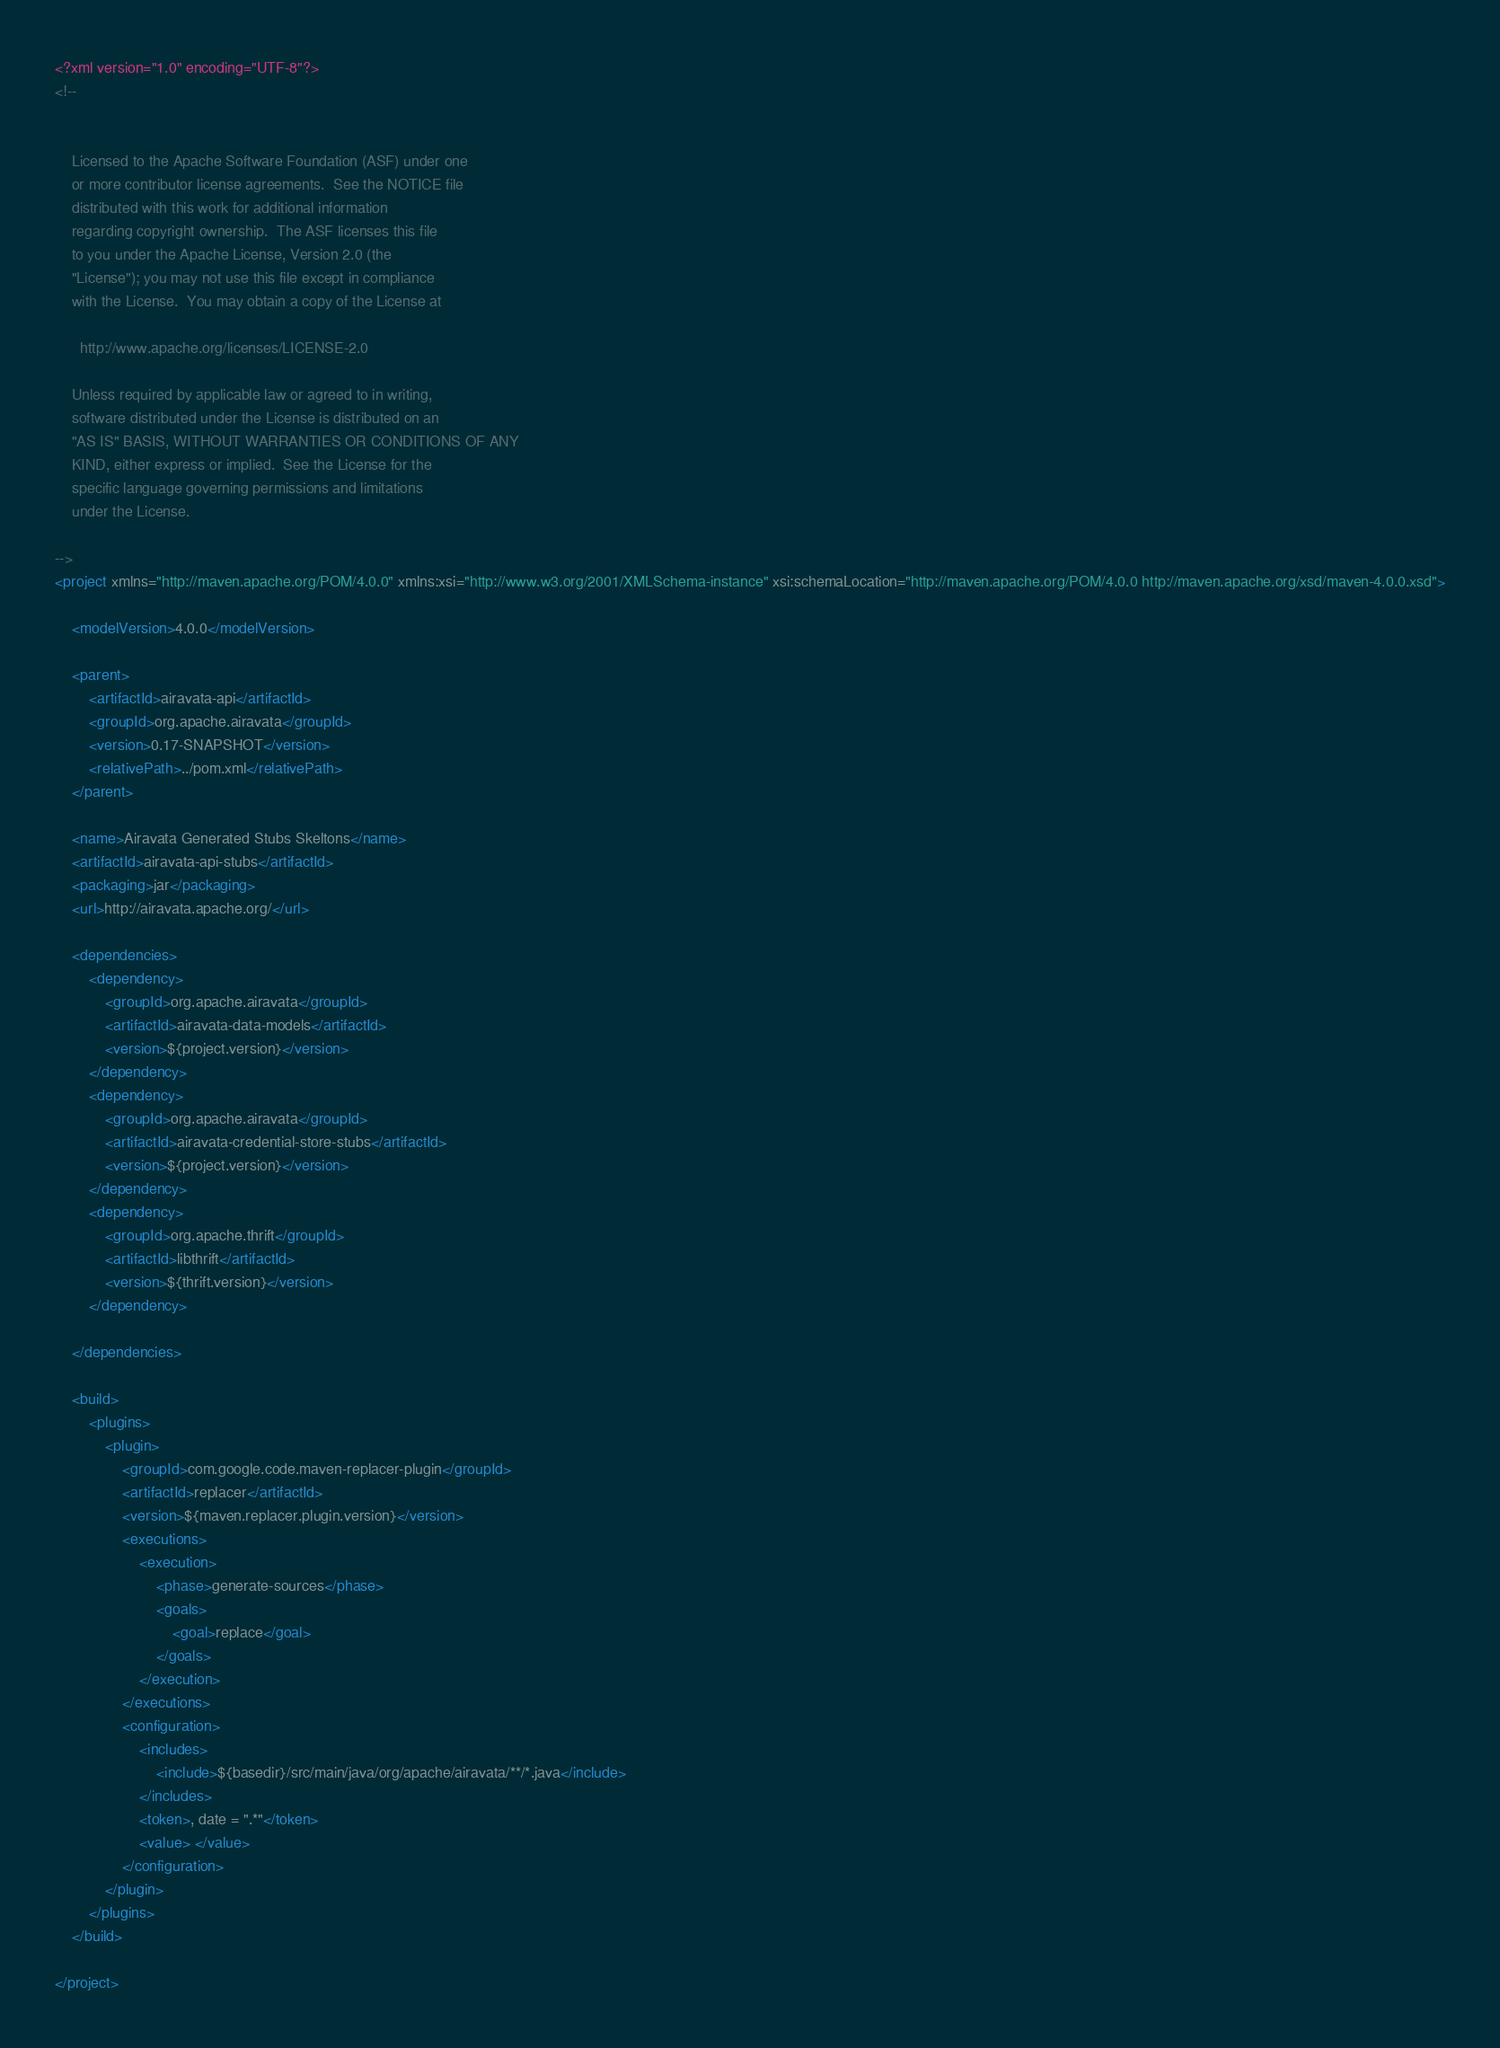Convert code to text. <code><loc_0><loc_0><loc_500><loc_500><_XML_><?xml version="1.0" encoding="UTF-8"?>
<!--


    Licensed to the Apache Software Foundation (ASF) under one
    or more contributor license agreements.  See the NOTICE file
    distributed with this work for additional information
    regarding copyright ownership.  The ASF licenses this file
    to you under the Apache License, Version 2.0 (the
    "License"); you may not use this file except in compliance
    with the License.  You may obtain a copy of the License at

      http://www.apache.org/licenses/LICENSE-2.0

    Unless required by applicable law or agreed to in writing,
    software distributed under the License is distributed on an
    "AS IS" BASIS, WITHOUT WARRANTIES OR CONDITIONS OF ANY
    KIND, either express or implied.  See the License for the
    specific language governing permissions and limitations
    under the License.

-->
<project xmlns="http://maven.apache.org/POM/4.0.0" xmlns:xsi="http://www.w3.org/2001/XMLSchema-instance" xsi:schemaLocation="http://maven.apache.org/POM/4.0.0 http://maven.apache.org/xsd/maven-4.0.0.xsd">

    <modelVersion>4.0.0</modelVersion>

    <parent>
        <artifactId>airavata-api</artifactId>
        <groupId>org.apache.airavata</groupId>
        <version>0.17-SNAPSHOT</version>
        <relativePath>../pom.xml</relativePath>
    </parent>

    <name>Airavata Generated Stubs Skeltons</name>
    <artifactId>airavata-api-stubs</artifactId>
    <packaging>jar</packaging>
    <url>http://airavata.apache.org/</url>

    <dependencies>
        <dependency>
            <groupId>org.apache.airavata</groupId>
            <artifactId>airavata-data-models</artifactId>
            <version>${project.version}</version>
        </dependency>
        <dependency>
            <groupId>org.apache.airavata</groupId>
            <artifactId>airavata-credential-store-stubs</artifactId>
            <version>${project.version}</version>
        </dependency>
        <dependency>
            <groupId>org.apache.thrift</groupId>
            <artifactId>libthrift</artifactId>
            <version>${thrift.version}</version>
        </dependency>

    </dependencies>

    <build>
        <plugins>
            <plugin>
                <groupId>com.google.code.maven-replacer-plugin</groupId>
                <artifactId>replacer</artifactId>
                <version>${maven.replacer.plugin.version}</version>
                <executions>
                    <execution>
                        <phase>generate-sources</phase>
                        <goals>
                            <goal>replace</goal>
                        </goals>
                    </execution>
                </executions>
                <configuration>
                    <includes>
                        <include>${basedir}/src/main/java/org/apache/airavata/**/*.java</include>
                    </includes>
                    <token>, date = ".*"</token>
                    <value> </value>
                </configuration>
            </plugin>
        </plugins>
    </build>

</project>
</code> 